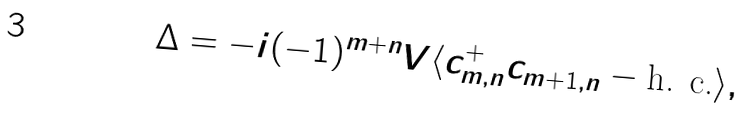<formula> <loc_0><loc_0><loc_500><loc_500>\Delta = - i ( - 1 ) ^ { m + n } V \langle c ^ { + } _ { m , n } c _ { m + 1 , n } - \text {h. c.} \rangle ,</formula> 